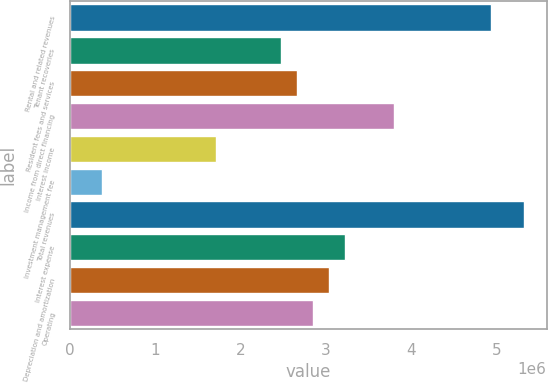Convert chart. <chart><loc_0><loc_0><loc_500><loc_500><bar_chart><fcel>Rental and related revenues<fcel>Tenant recoveries<fcel>Resident fees and services<fcel>Income from direct financing<fcel>Interest income<fcel>Investment management fee<fcel>Total revenues<fcel>Interest expense<fcel>Depreciation and amortization<fcel>Operating<nl><fcel>4.94188e+06<fcel>2.47094e+06<fcel>2.66101e+06<fcel>3.80144e+06<fcel>1.71065e+06<fcel>380144<fcel>5.32202e+06<fcel>3.23123e+06<fcel>3.04116e+06<fcel>2.85108e+06<nl></chart> 